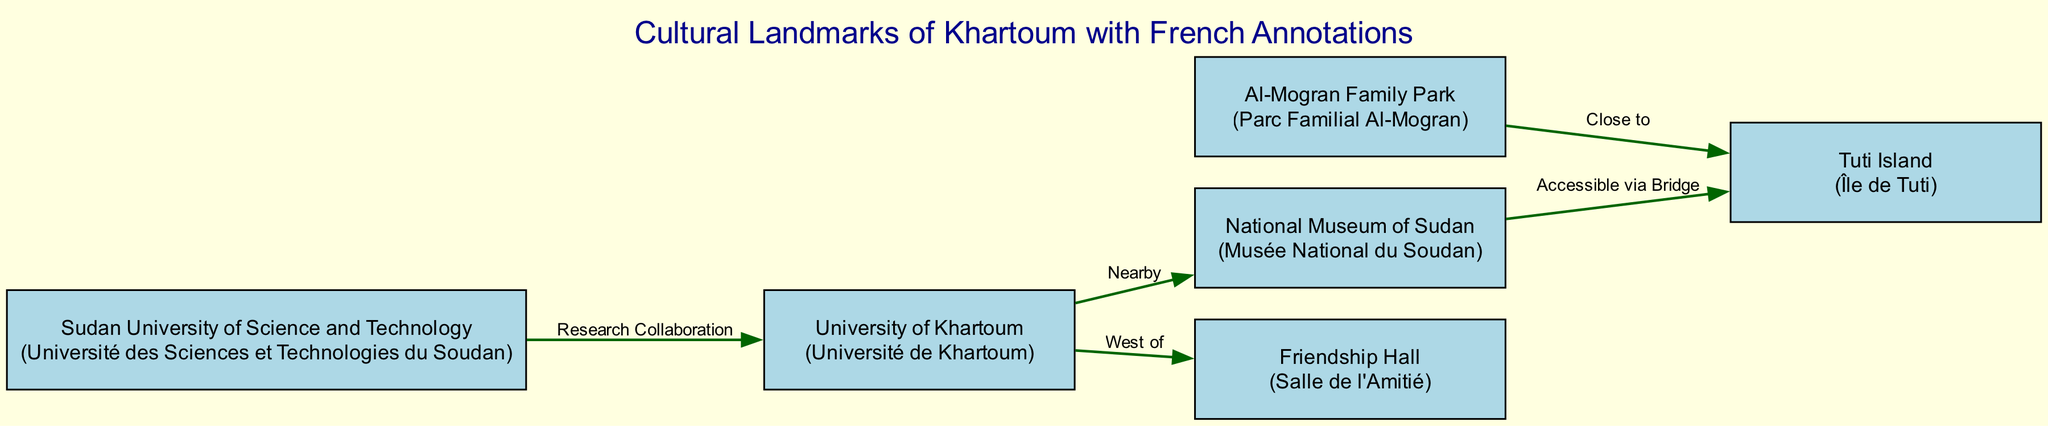What is the annotation for the National Museum of Sudan? The label for the National Museum of Sudan in the diagram is "Musée National du Soudan," which is provided in parentheses next to the landmark's main name.
Answer: Musée National du Soudan How many landmarks are present in the diagram? The diagram lists a total of six landmarks. Each landmark is represented as a separate node in the data, allowing for a count of six.
Answer: 6 Which landmark is accessible via a bridge? According to the diagram, the National Museum of Sudan is noted as accessible via a bridge to Tuti Island, signifying a direct connection.
Answer: Tuti Island What is located west of the University of Khartoum? The diagram specifies that the Friendship Hall is west of the University of Khartoum, indicating its relative position in relation to the university.
Answer: Friendship Hall Which two landmarks are close to Tuti Island? Based on the diagram, both the National Museum of Sudan and Al-Mogran Family Park have relationships with Tuti Island; the former via bridge access and the latter being close.
Answer: National Museum of Sudan and Al-Mogran Family Park What type of relationship exists between Sudan University of Science and Technology and University of Khartoum? The diagram indicates a "Research Collaboration" relationship between Sudan University of Science and Technology and University of Khartoum, showcasing interaction between these two educational landmarks.
Answer: Research Collaboration How many edges connect the University of Khartoum? The University of Khartoum connects with two other landmarks: the National Museum of Sudan (nearby) and the Friendship Hall (west of). This results in a total of two edges.
Answer: 2 What does the edge labeled "Close to" indicate in the diagram? The edge labeled "Close to" indicates the relationship between Al-Mogran Family Park and Tuti Island, illustrating their proximity to each other in the context of the diagram.
Answer: Al-Mogran Family Park and Tuti Island In what direction is the Friendship Hall located from the University of Khartoum? According to the diagram, the Friendship Hall is located west of the University of Khartoum, showing directional information in relation to the university.
Answer: West 